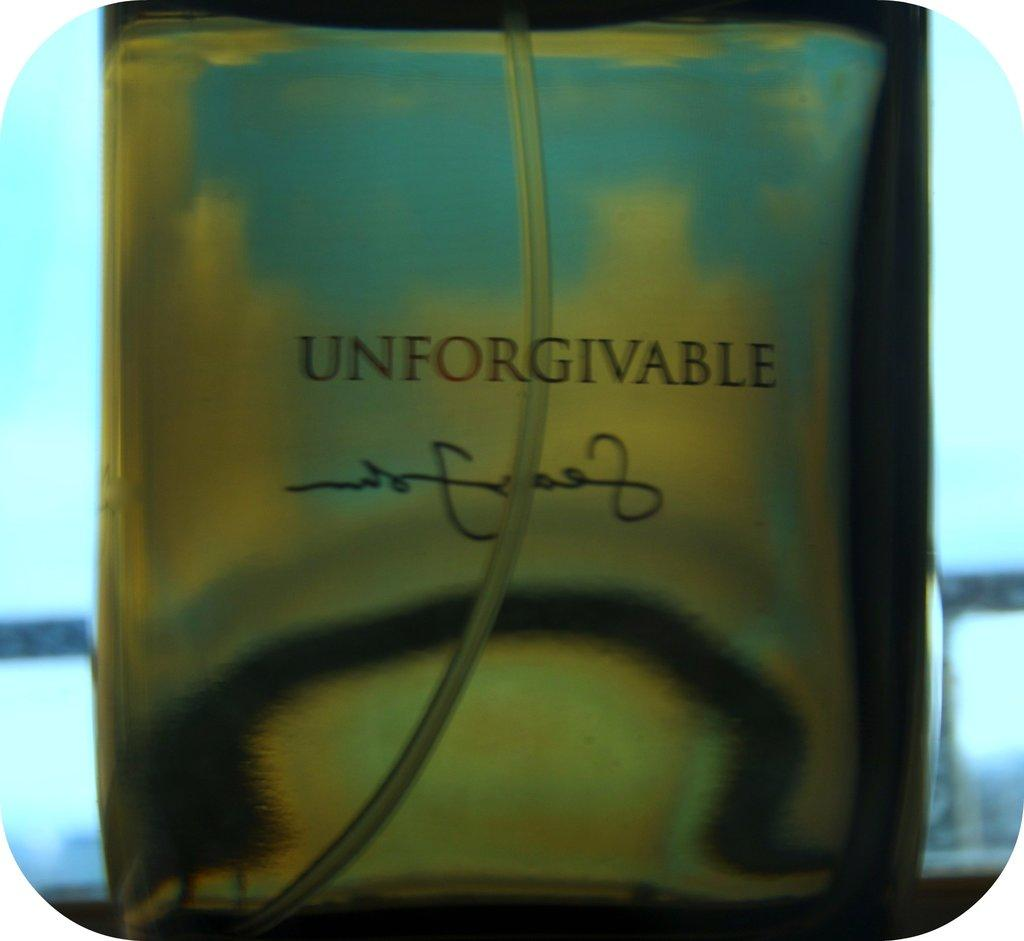<image>
Give a short and clear explanation of the subsequent image. Aperfume bottle labeled unforgivable with the tube for the pump nozzle in it. 